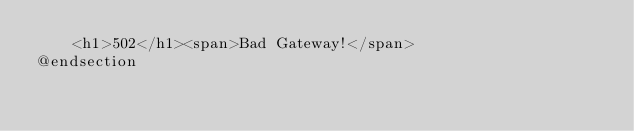Convert code to text. <code><loc_0><loc_0><loc_500><loc_500><_PHP_>    <h1>502</h1><span>Bad Gateway!</span>
@endsection
</code> 